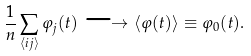Convert formula to latex. <formula><loc_0><loc_0><loc_500><loc_500>\frac { 1 } { n } \sum _ { \langle i j \rangle } \varphi _ { j } ( t ) \longrightarrow \langle \varphi ( t ) \rangle \equiv \varphi _ { 0 } ( t ) .</formula> 